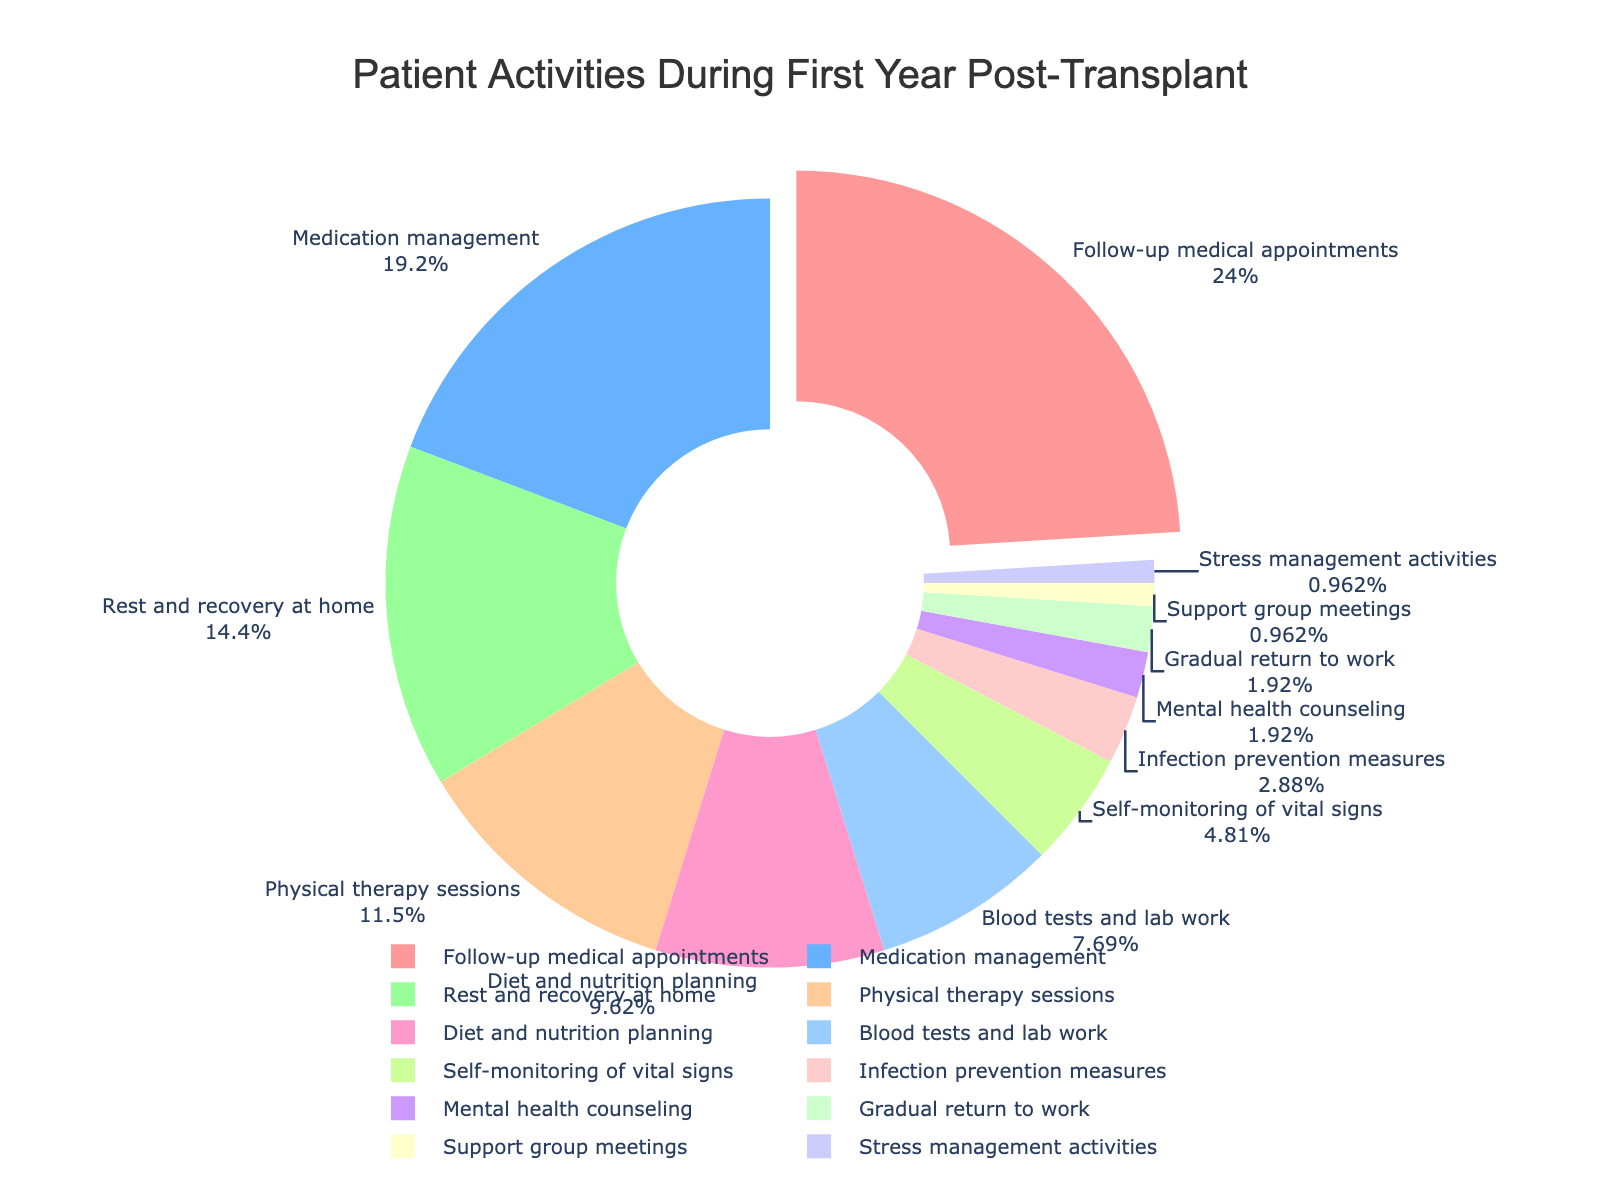Which activity takes up the largest percentage of the first year post-transplant recovery period? The pie chart shows that the activity with the largest percentage is marked as "Follow-up medical appointments."
Answer: Follow-up medical appointments What activities take up more than 20% of the time during the first year post-transplant? The pie chart shows that "Follow-up medical appointments" and "Medication management" each take up more than 20%.
Answer: Follow-up medical appointments, Medication management What activities take up less than 5% of the time collectively during the first year post-transplant? The pie chart shows that "Self-monitoring of vital signs," "Infection prevention measures," "Mental health counseling," "Gradual return to work," "Support group meetings," and "Stress management activities" each take up less than 5%. Summing them, we get 5% + 3% + 2% + 2% + 1% + 1% = 14%.
Answer: Self-monitoring of vital signs, Infection prevention measures, Mental health counseling, Gradual return to work, Support group meetings, Stress management activities What is the combined percentage of time spent on physical therapy sessions and diet and nutrition planning? According to the pie chart, physical therapy sessions take up 12% and diet and nutrition planning takes up 10%. Summing them, 12% + 10% = 22%.
Answer: 22% Which activity takes the least percentage of the time and how much is it? The pie chart shows that "Stress management activities" and "Support group meetings" each take up the least amount of time, both being 1%.
Answer: Stress management activities, Support group meetings, 1% How much more time is spent on follow-up medical appointments than on blood tests and lab work? Follow-up medical appointments take 25% of the time, while blood tests and lab work take 8%. The difference is 25% - 8% = 17%.
Answer: 17% Is more time spent on physical therapy sessions or on diet and nutrition planning? According to the pie chart, physical therapy sessions take up 12% and diet and nutrition planning takes up 10%. Physical therapy sessions account for more time.
Answer: Physical therapy sessions What is the difference in percentage between the highest and lowest activity times? The pie chart shows that the highest activity time is 25% (Follow-up medical appointments) and the lowest activities are 1% (Stress management activities and Support group meetings). The difference is 25% - 1% = 24%.
Answer: 24% Which activities have a percentage that is a multiple of 5? According to the pie chart, the activities that have percentages that are multiples of 5 include "Follow-up medical appointments" (25%), "Medication management" (20%), "Rest and recovery at home" (15%), and "Self-monitoring of vital signs" (5%).
Answer: Follow-up medical appointments, Medication management, Rest and recovery at home, Self-monitoring of vital signs 